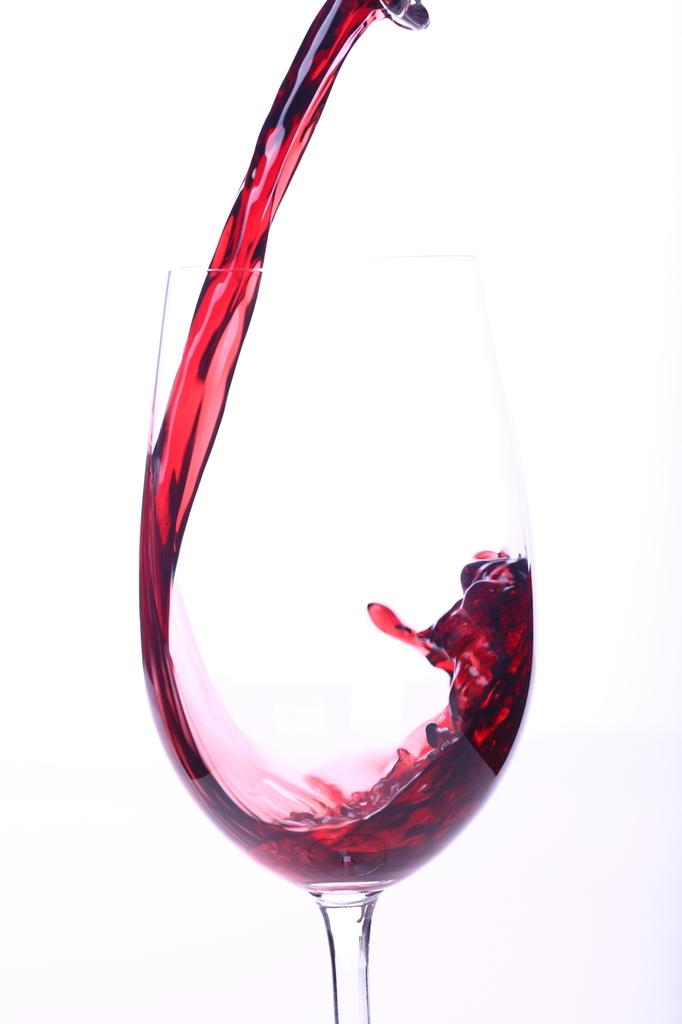What type of object is at the top of the image? There is a steel object at the top of the image. What is coming out of the steel object? Red wine is pouring from the steel object. What is the wine pouring into? The wine is pouring into a wine glass. What can be seen in the background of the image? There is brightness visible in the background of the image. How many chairs are visible in the image? There are no chairs present in the image. What type of geese can be seen in the image? There are no geese present in the image. 